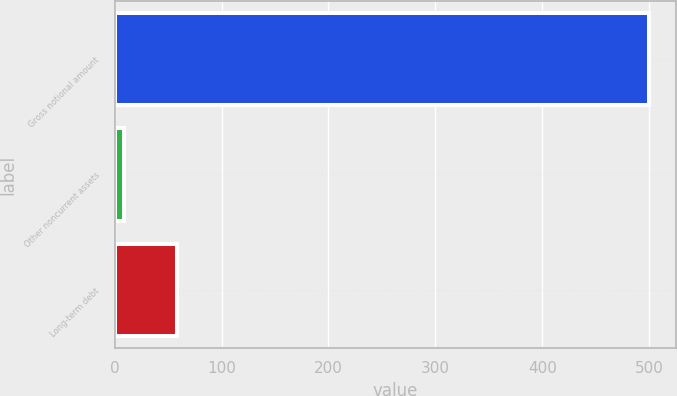Convert chart. <chart><loc_0><loc_0><loc_500><loc_500><bar_chart><fcel>Gross notional amount<fcel>Other noncurrent assets<fcel>Long-term debt<nl><fcel>500<fcel>9<fcel>58.1<nl></chart> 